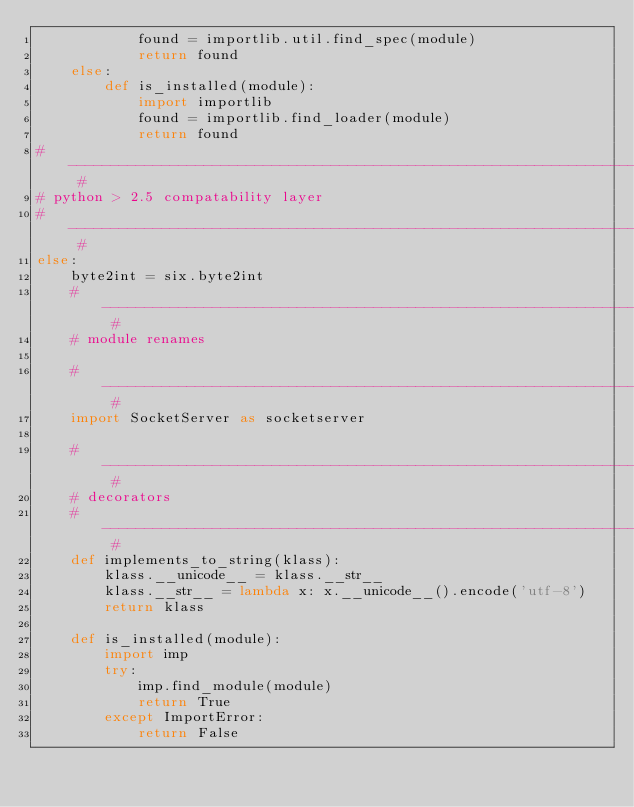Convert code to text. <code><loc_0><loc_0><loc_500><loc_500><_Python_>            found = importlib.util.find_spec(module)
            return found
    else:
        def is_installed(module):
            import importlib
            found = importlib.find_loader(module)
            return found
# --------------------------------------------------------------------------- #
# python > 2.5 compatability layer
# --------------------------------------------------------------------------- #
else:
    byte2int = six.byte2int
    # ----------------------------------------------------------------------- #
    # module renames

    # ----------------------------------------------------------------------- #
    import SocketServer as socketserver

    # ----------------------------------------------------------------------- #
    # decorators
    # ----------------------------------------------------------------------- #
    def implements_to_string(klass):
        klass.__unicode__ = klass.__str__
        klass.__str__ = lambda x: x.__unicode__().encode('utf-8')
        return klass

    def is_installed(module):
        import imp
        try:
            imp.find_module(module)
            return True
        except ImportError:
            return False</code> 